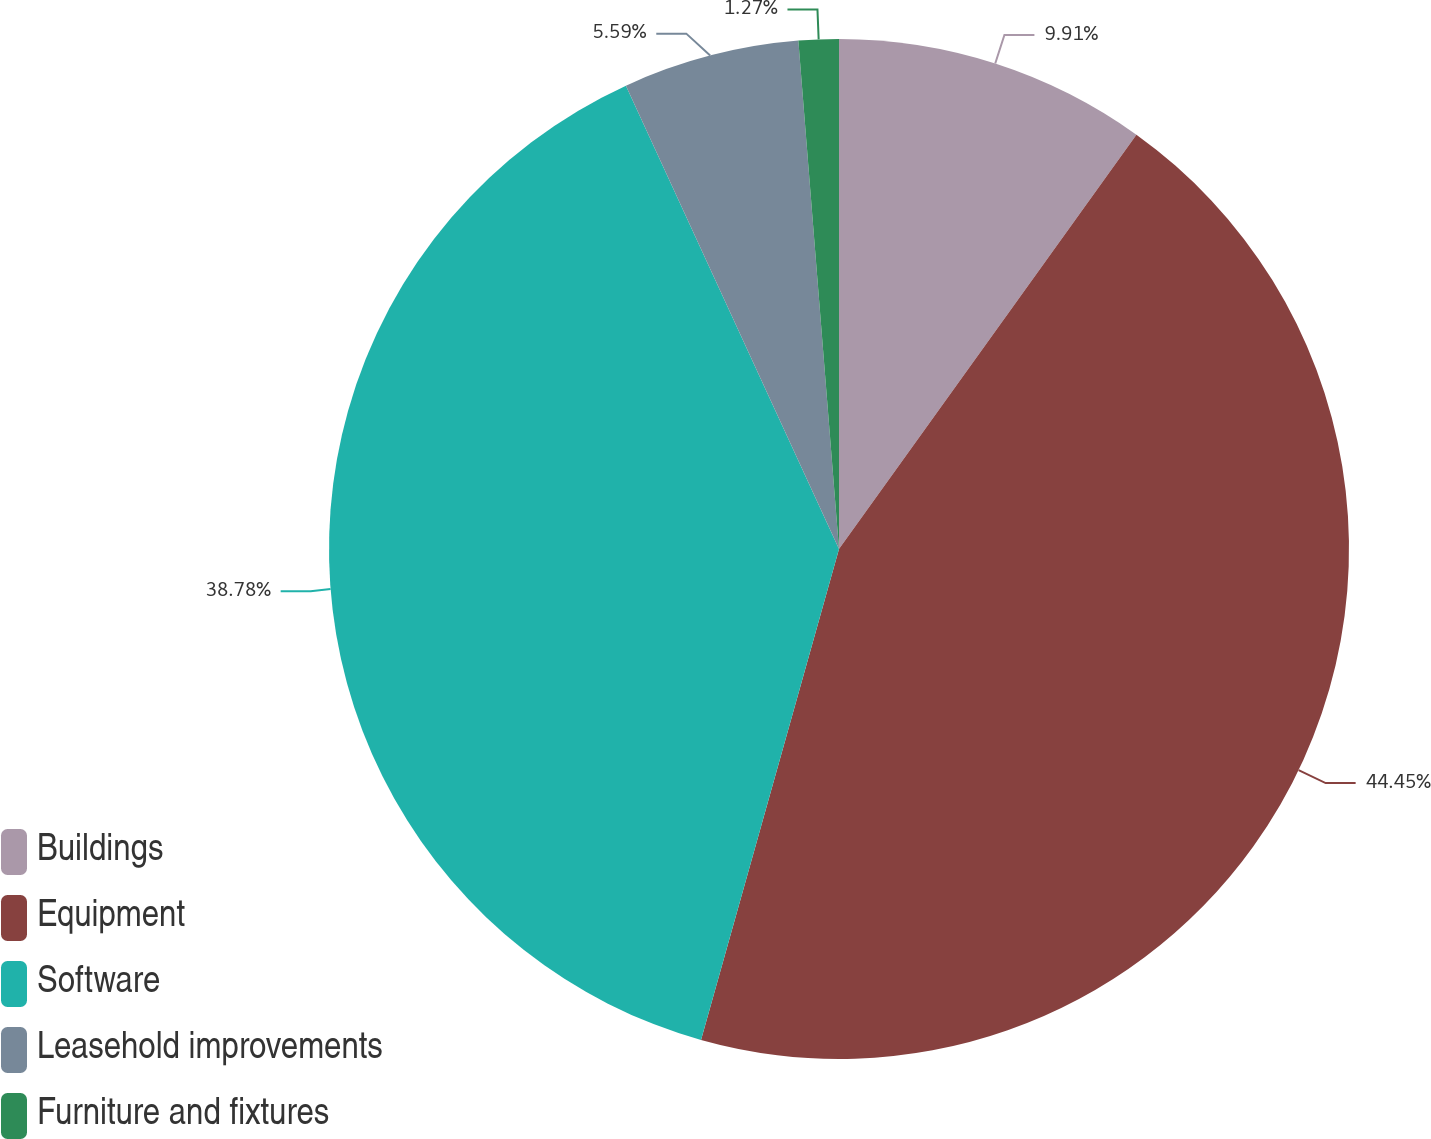<chart> <loc_0><loc_0><loc_500><loc_500><pie_chart><fcel>Buildings<fcel>Equipment<fcel>Software<fcel>Leasehold improvements<fcel>Furniture and fixtures<nl><fcel>9.91%<fcel>44.45%<fcel>38.78%<fcel>5.59%<fcel>1.27%<nl></chart> 